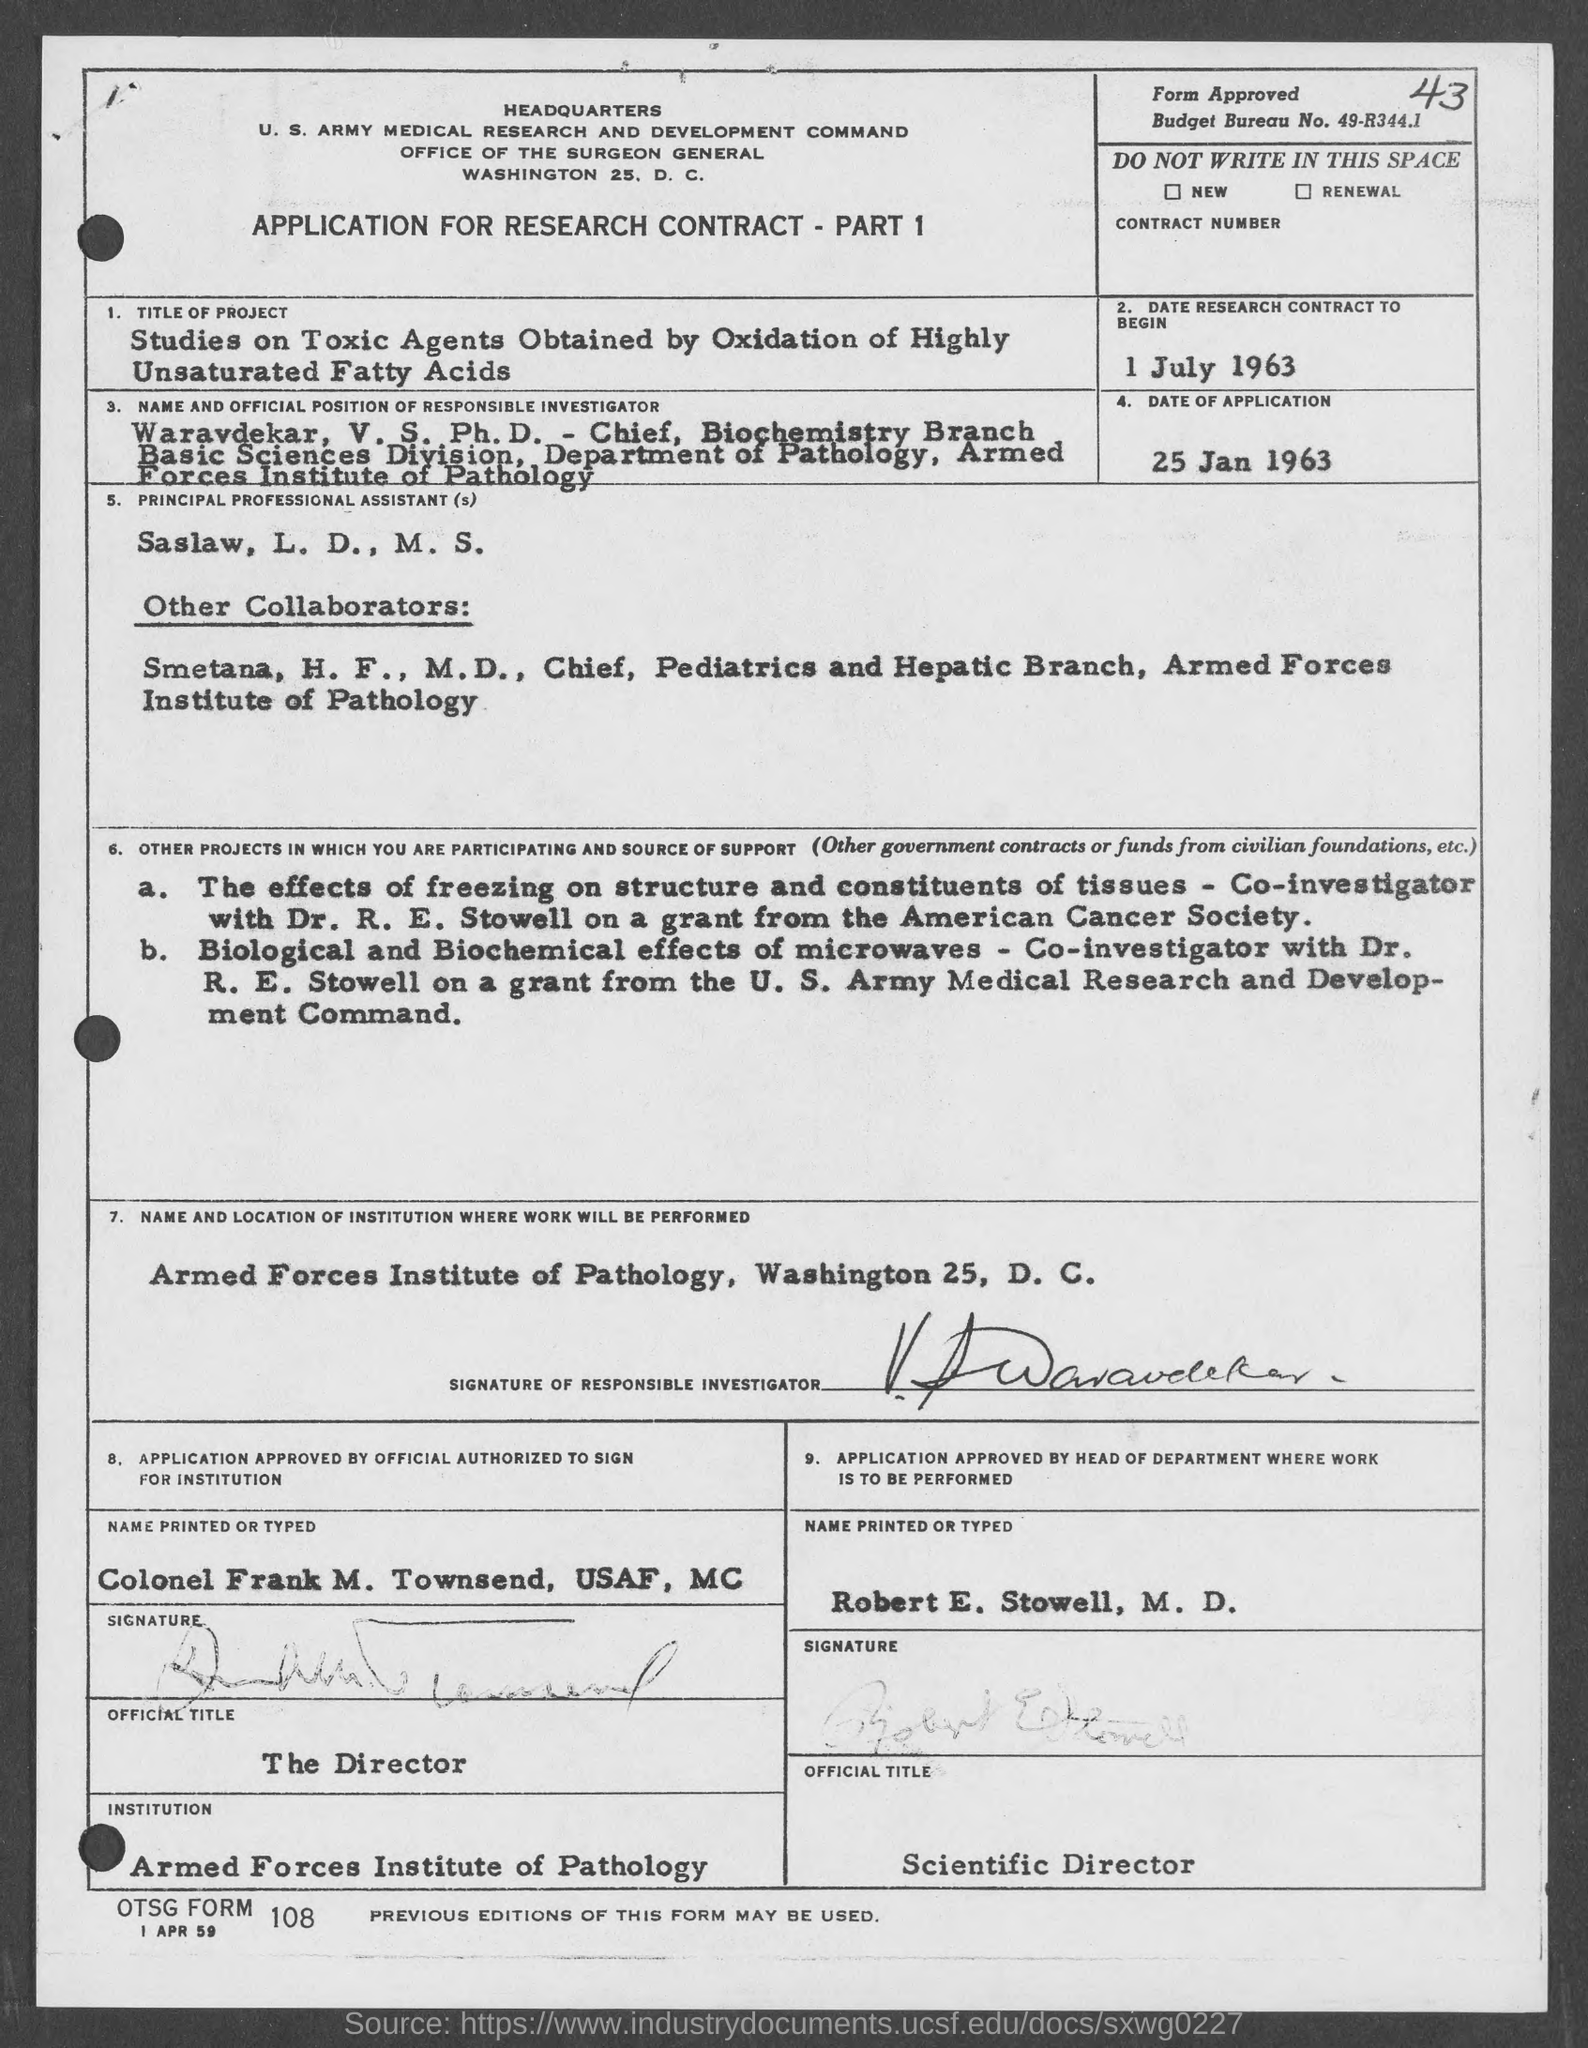What is the Budget Bureau No. given in the application?
Provide a succinct answer. 49-R344.1. What is the date of the application given?
Keep it short and to the point. 25 Jan 1963. What is the date of research contract to begin?
Your response must be concise. 1 July 1963. What is the title of the project given in the application?
Provide a short and direct response. Studies on Toxic Agents Obtained by Oxidation of Highly Unsaturated Fatty Acids. What is the name of the responsible investigator given in the application?
Your response must be concise. Waravdekar, V. S. Who is the Principal Professional Assistant as per the application?
Your response must be concise. Saslaw, L. D., M. S. What is the name and location of institution where work will be performed?
Your response must be concise. Armed Forces Institute of Pathology, Washington 25, D. C. What is the official title of Robert E. Stowell, M. D.?
Keep it short and to the point. Scientific Director. 